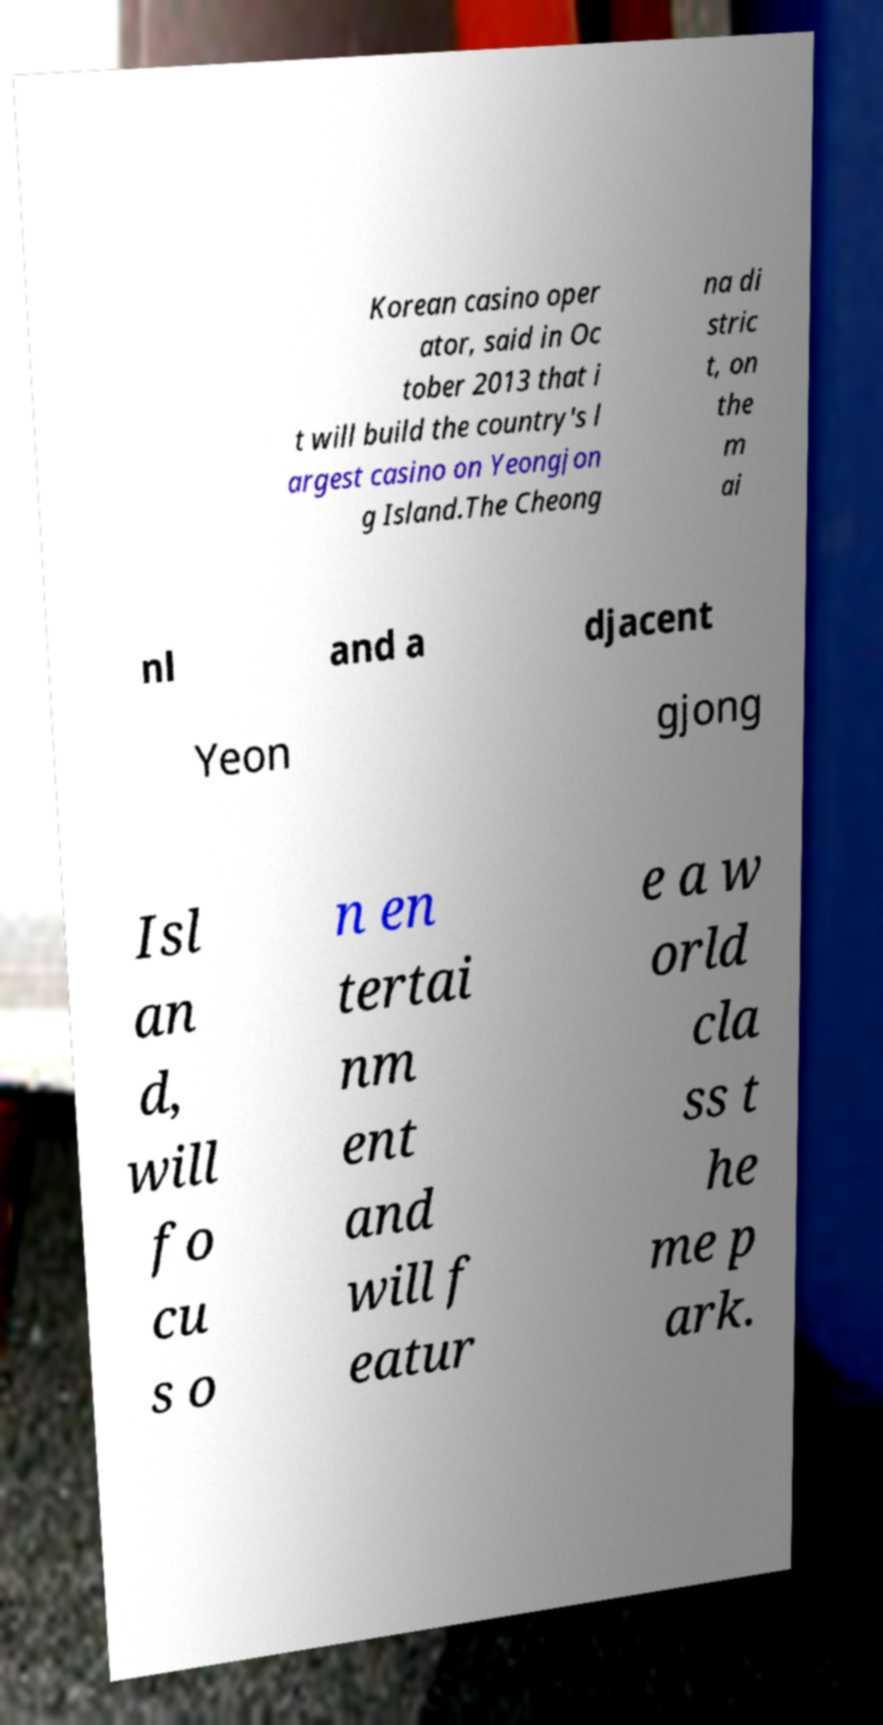I need the written content from this picture converted into text. Can you do that? Korean casino oper ator, said in Oc tober 2013 that i t will build the country's l argest casino on Yeongjon g Island.The Cheong na di stric t, on the m ai nl and a djacent Yeon gjong Isl an d, will fo cu s o n en tertai nm ent and will f eatur e a w orld cla ss t he me p ark. 